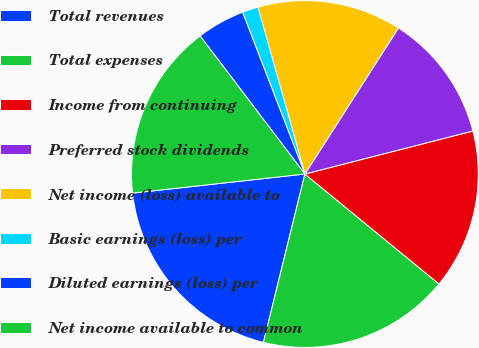Convert chart. <chart><loc_0><loc_0><loc_500><loc_500><pie_chart><fcel>Total revenues<fcel>Total expenses<fcel>Income from continuing<fcel>Preferred stock dividends<fcel>Net income (loss) available to<fcel>Basic earnings (loss) per<fcel>Diluted earnings (loss) per<fcel>Net income available to common<nl><fcel>19.4%<fcel>17.91%<fcel>14.92%<fcel>11.94%<fcel>13.43%<fcel>1.49%<fcel>4.48%<fcel>16.42%<nl></chart> 